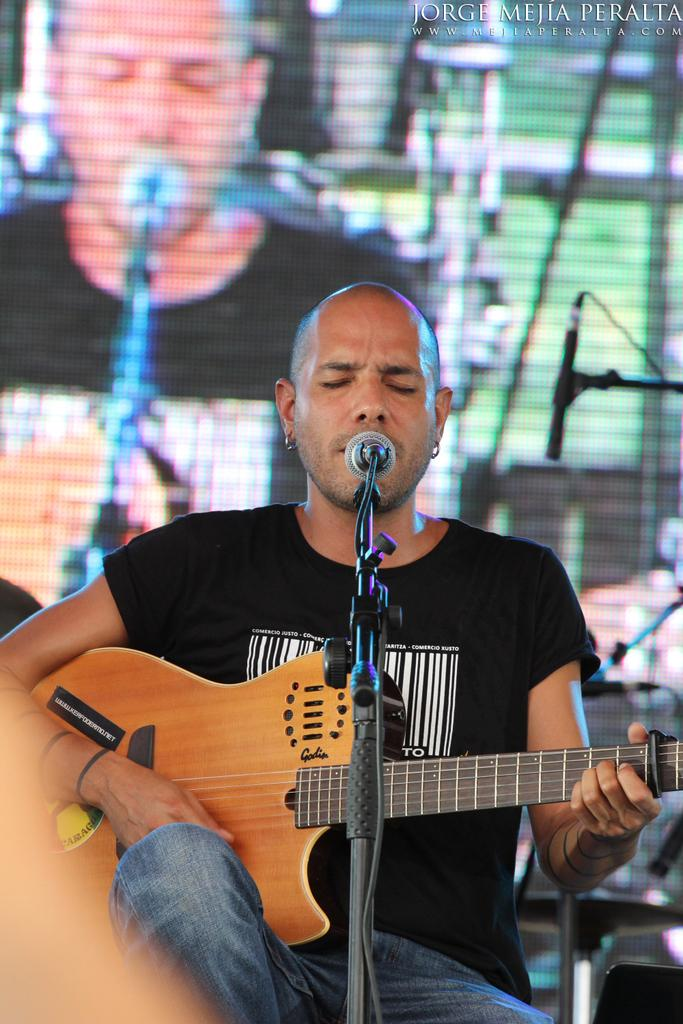Who is the person in the image? There is a man in the image. What is the man doing in the image? The man is seated and playing a guitar. What object is present in the image that is typically used for amplifying sound? There is a microphone in the image. What type of bread can be seen in the image? There is no bread present in the image. What color is the box that the man is sitting on? There is no box present in the image; the man is seated on a chair or a stool. 